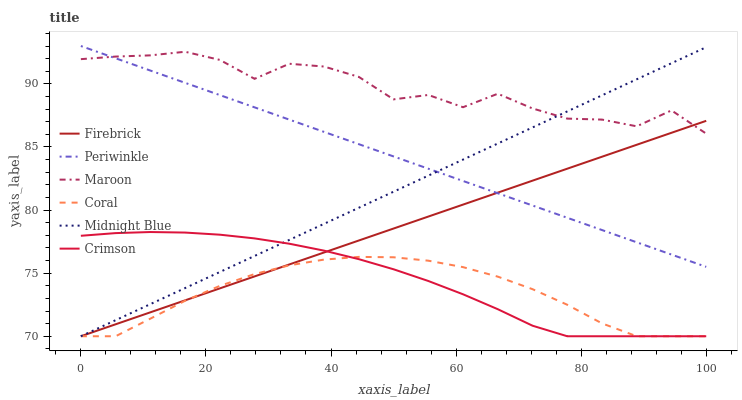Does Coral have the minimum area under the curve?
Answer yes or no. Yes. Does Maroon have the maximum area under the curve?
Answer yes or no. Yes. Does Firebrick have the minimum area under the curve?
Answer yes or no. No. Does Firebrick have the maximum area under the curve?
Answer yes or no. No. Is Firebrick the smoothest?
Answer yes or no. Yes. Is Maroon the roughest?
Answer yes or no. Yes. Is Maroon the smoothest?
Answer yes or no. No. Is Firebrick the roughest?
Answer yes or no. No. Does Midnight Blue have the lowest value?
Answer yes or no. Yes. Does Maroon have the lowest value?
Answer yes or no. No. Does Periwinkle have the highest value?
Answer yes or no. Yes. Does Firebrick have the highest value?
Answer yes or no. No. Is Crimson less than Periwinkle?
Answer yes or no. Yes. Is Periwinkle greater than Crimson?
Answer yes or no. Yes. Does Crimson intersect Firebrick?
Answer yes or no. Yes. Is Crimson less than Firebrick?
Answer yes or no. No. Is Crimson greater than Firebrick?
Answer yes or no. No. Does Crimson intersect Periwinkle?
Answer yes or no. No. 